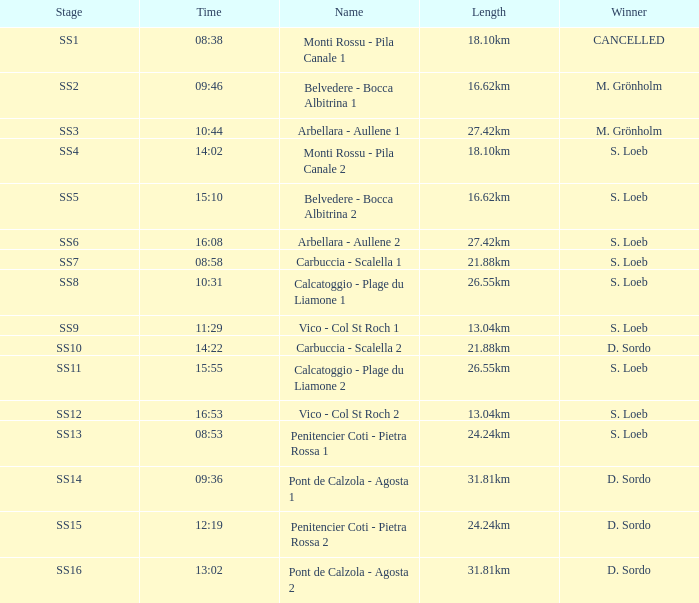What is the Name of the SS5 Stage? Belvedere - Bocca Albitrina 2. 